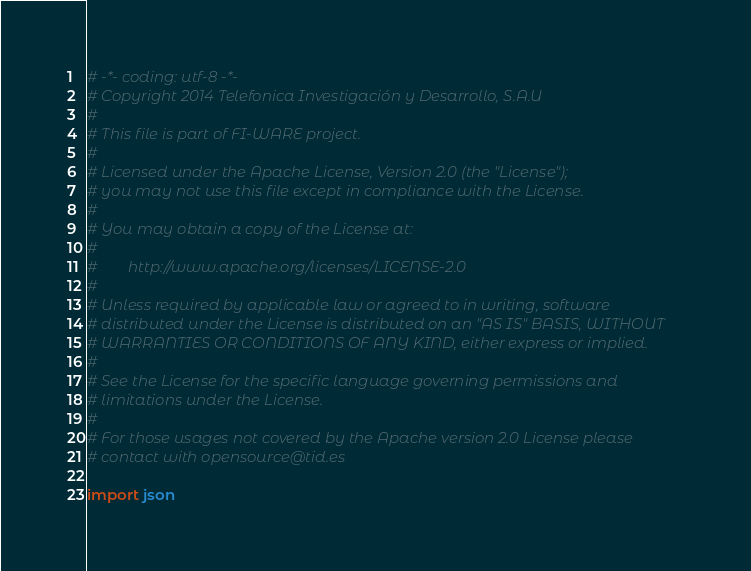Convert code to text. <code><loc_0><loc_0><loc_500><loc_500><_Python_># -*- coding: utf-8 -*-
# Copyright 2014 Telefonica Investigación y Desarrollo, S.A.U
#
# This file is part of FI-WARE project.
#
# Licensed under the Apache License, Version 2.0 (the "License");
# you may not use this file except in compliance with the License.
#
# You may obtain a copy of the License at:
#
#        http://www.apache.org/licenses/LICENSE-2.0
#
# Unless required by applicable law or agreed to in writing, software
# distributed under the License is distributed on an "AS IS" BASIS, WITHOUT
# WARRANTIES OR CONDITIONS OF ANY KIND, either express or implied.
#
# See the License for the specific language governing permissions and
# limitations under the License.
#
# For those usages not covered by the Apache version 2.0 License please
# contact with opensource@tid.es

import json</code> 